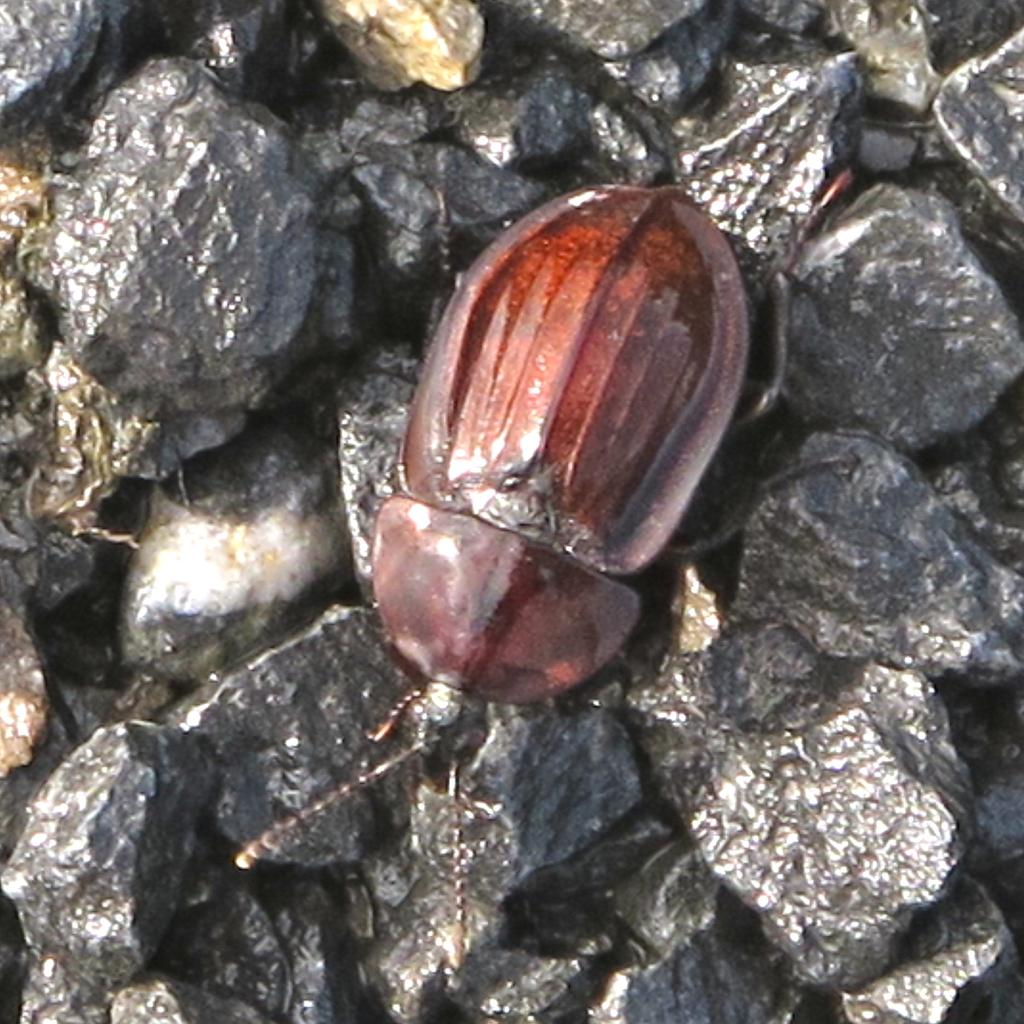What type of creature is present in the image? There is an insect in the image. Where is the insect located? The insect is on stones. What type of cactus can be heard making a sound in the image? There is no cactus or sound present in the image; it features an insect on stones. 